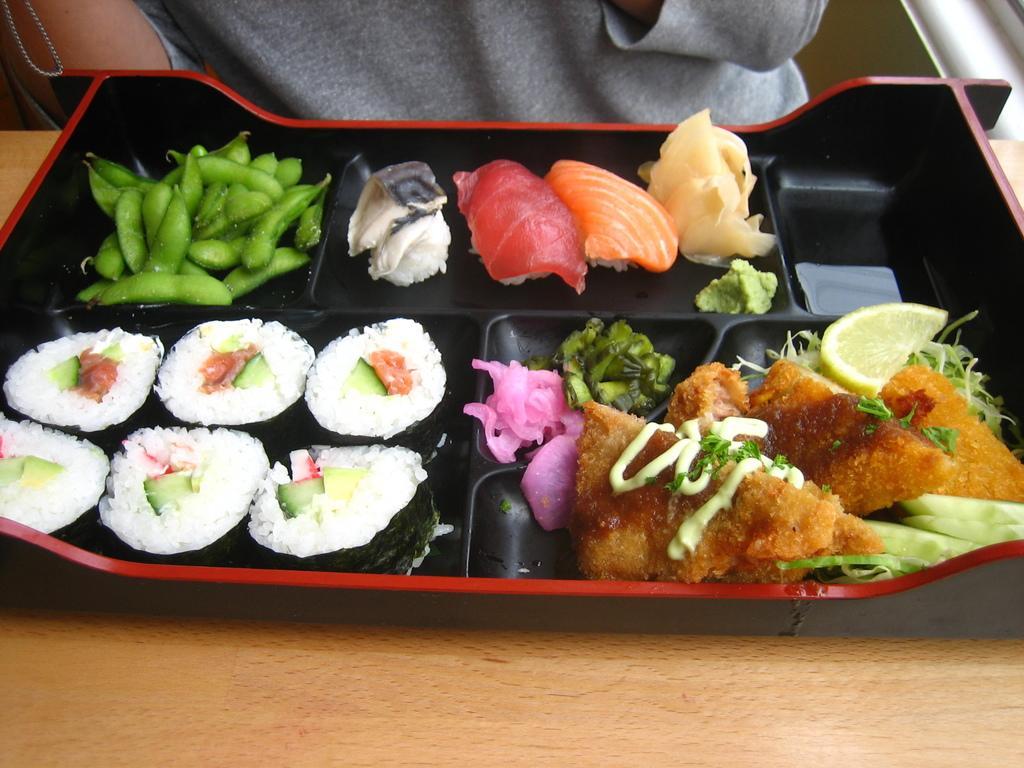Could you give a brief overview of what you see in this image? In this image, we can see some food items on the tray, which is placed on the table. In the background, there is a person. 